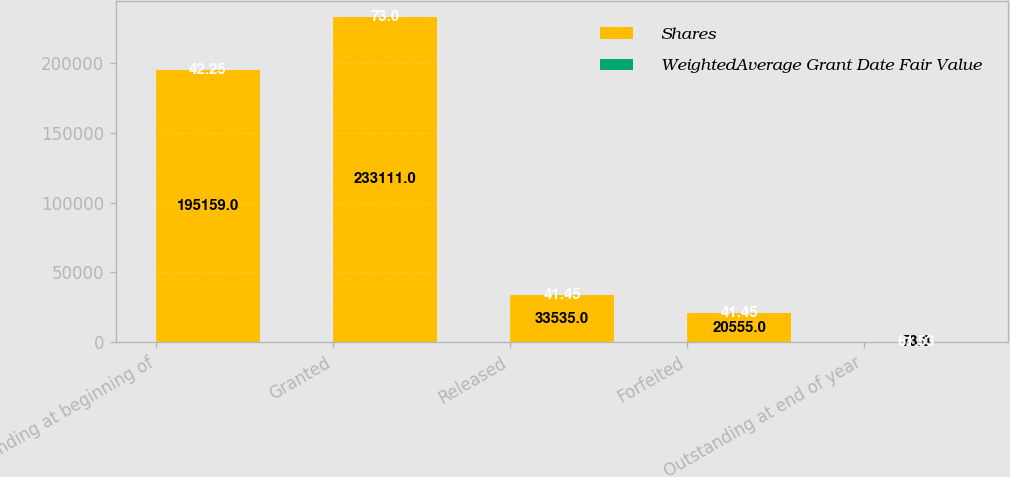Convert chart to OTSL. <chart><loc_0><loc_0><loc_500><loc_500><stacked_bar_chart><ecel><fcel>Outstanding at beginning of<fcel>Granted<fcel>Released<fcel>Forfeited<fcel>Outstanding at end of year<nl><fcel>Shares<fcel>195159<fcel>233111<fcel>33535<fcel>20555<fcel>73<nl><fcel>WeightedAverage Grant Date Fair Value<fcel>42.25<fcel>73<fcel>41.45<fcel>41.45<fcel>61.53<nl></chart> 